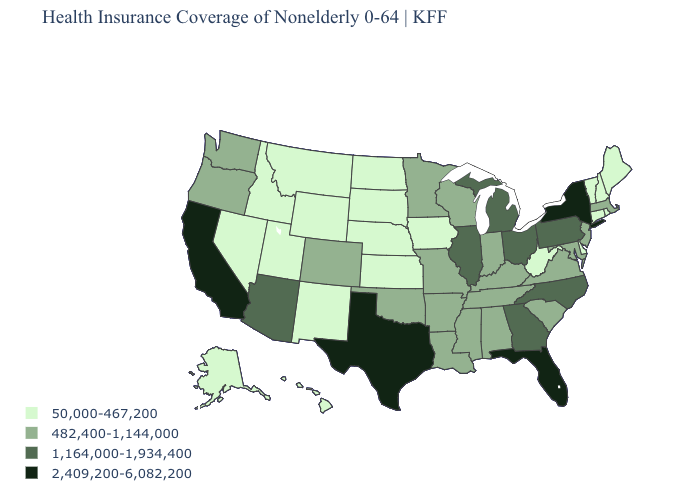What is the value of Indiana?
Give a very brief answer. 482,400-1,144,000. What is the value of Arizona?
Be succinct. 1,164,000-1,934,400. Does New York have the highest value in the USA?
Quick response, please. Yes. How many symbols are there in the legend?
Concise answer only. 4. Among the states that border South Dakota , does Montana have the lowest value?
Quick response, please. Yes. Among the states that border Texas , does New Mexico have the highest value?
Quick response, please. No. What is the lowest value in the West?
Answer briefly. 50,000-467,200. What is the value of Arizona?
Quick response, please. 1,164,000-1,934,400. What is the value of Pennsylvania?
Write a very short answer. 1,164,000-1,934,400. What is the lowest value in states that border Florida?
Give a very brief answer. 482,400-1,144,000. Name the states that have a value in the range 50,000-467,200?
Write a very short answer. Alaska, Connecticut, Delaware, Hawaii, Idaho, Iowa, Kansas, Maine, Montana, Nebraska, Nevada, New Hampshire, New Mexico, North Dakota, Rhode Island, South Dakota, Utah, Vermont, West Virginia, Wyoming. Is the legend a continuous bar?
Concise answer only. No. Among the states that border Iowa , which have the highest value?
Concise answer only. Illinois. What is the value of Massachusetts?
Write a very short answer. 482,400-1,144,000. Does Kansas have the same value as Montana?
Give a very brief answer. Yes. 